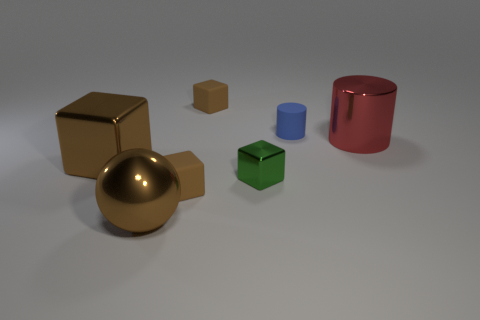Subtract all big brown shiny cubes. How many cubes are left? 3 Subtract all brown spheres. How many brown blocks are left? 3 Subtract all green blocks. How many blocks are left? 3 Add 1 green blocks. How many objects exist? 8 Subtract all gray cubes. Subtract all green spheres. How many cubes are left? 4 Subtract all cubes. How many objects are left? 3 Add 6 small brown things. How many small brown things are left? 8 Add 1 big yellow metal blocks. How many big yellow metal blocks exist? 1 Subtract 1 brown spheres. How many objects are left? 6 Subtract all tiny brown metal cylinders. Subtract all red things. How many objects are left? 6 